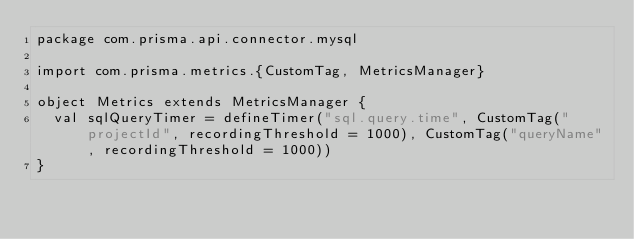Convert code to text. <code><loc_0><loc_0><loc_500><loc_500><_Scala_>package com.prisma.api.connector.mysql

import com.prisma.metrics.{CustomTag, MetricsManager}

object Metrics extends MetricsManager {
  val sqlQueryTimer = defineTimer("sql.query.time", CustomTag("projectId", recordingThreshold = 1000), CustomTag("queryName", recordingThreshold = 1000))
}
</code> 